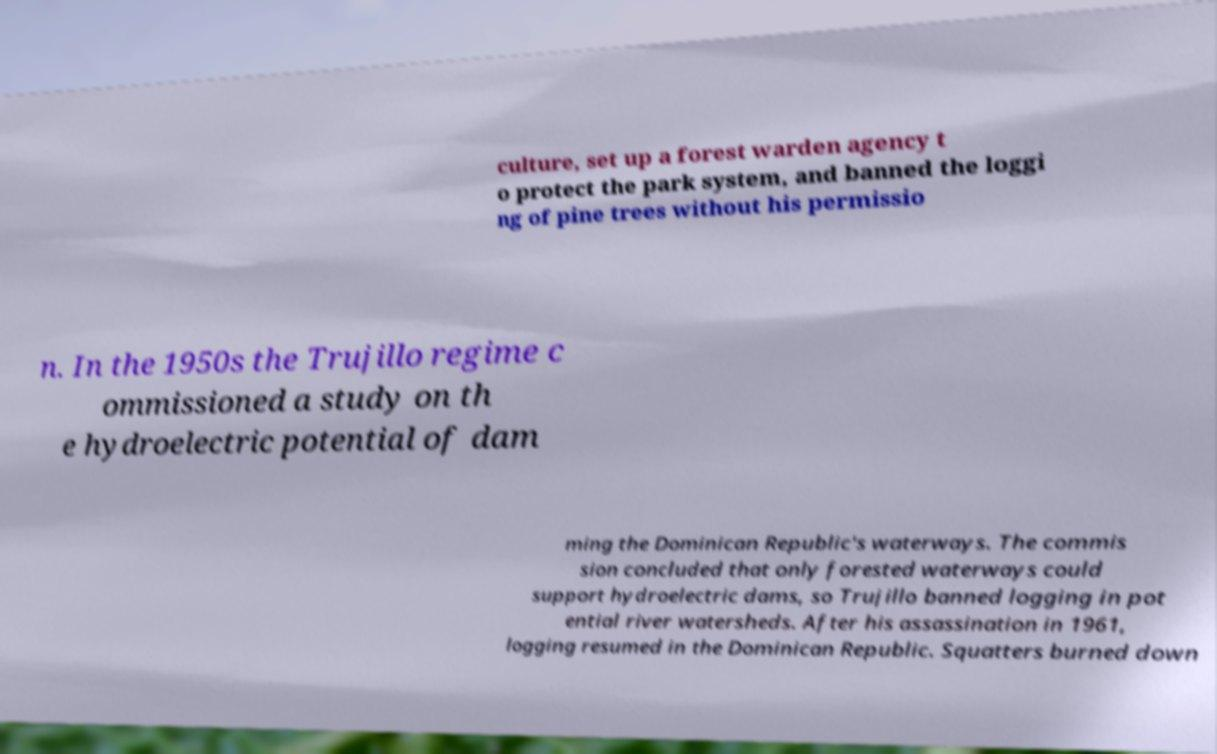Can you read and provide the text displayed in the image?This photo seems to have some interesting text. Can you extract and type it out for me? culture, set up a forest warden agency t o protect the park system, and banned the loggi ng of pine trees without his permissio n. In the 1950s the Trujillo regime c ommissioned a study on th e hydroelectric potential of dam ming the Dominican Republic's waterways. The commis sion concluded that only forested waterways could support hydroelectric dams, so Trujillo banned logging in pot ential river watersheds. After his assassination in 1961, logging resumed in the Dominican Republic. Squatters burned down 